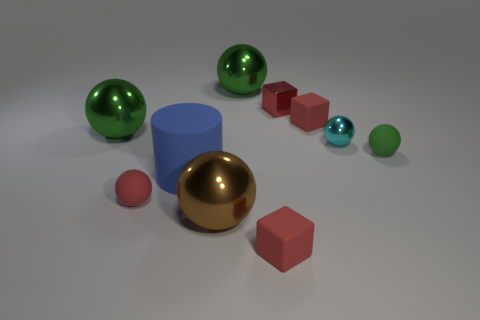Does the small rubber object in front of the red sphere have the same color as the rubber sphere that is on the left side of the green matte thing?
Your response must be concise. Yes. What is the material of the large brown ball on the right side of the tiny sphere that is to the left of the red cube that is in front of the brown ball?
Your answer should be compact. Metal. Is the shape of the blue object the same as the large brown metallic thing?
Provide a succinct answer. No. How many rubber things are red cubes or red things?
Provide a succinct answer. 3. How many large green balls are there?
Make the answer very short. 2. There is a shiny block that is the same size as the cyan ball; what color is it?
Keep it short and to the point. Red. Do the cyan object and the blue object have the same size?
Offer a terse response. No. There is a blue matte thing; is it the same size as the green ball that is behind the shiny block?
Your response must be concise. Yes. The ball that is both behind the red rubber sphere and in front of the tiny cyan object is what color?
Your answer should be compact. Green. Is the number of things right of the big brown shiny ball greater than the number of green rubber spheres in front of the small red metal thing?
Provide a short and direct response. Yes. 